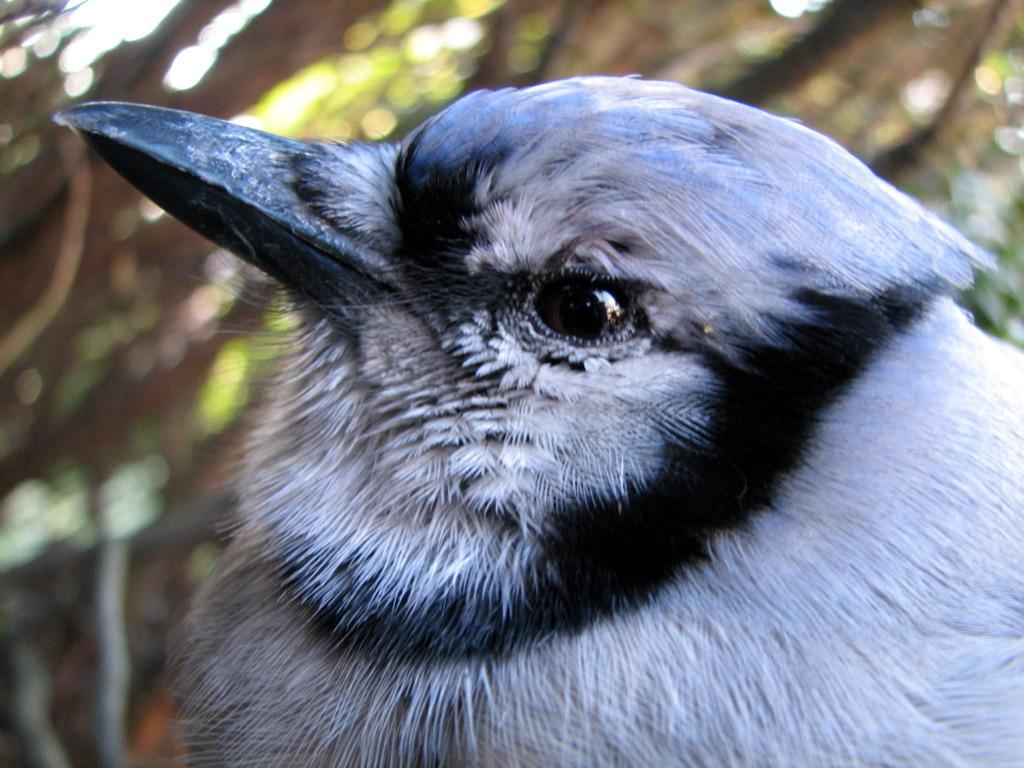What type of animal is present in the image? There is a bird in the image. Can you describe the color of the bird? The bird is black and white in color. What type of doctor is treating the bird in the image? There is no doctor present in the image, nor is the bird being treated by a doctor. 